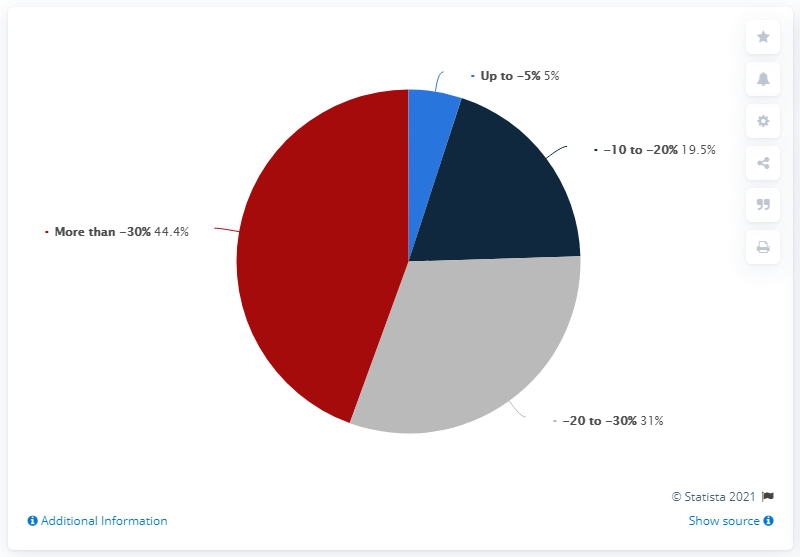Outline some significant characteristics in this image. The color blue is used to represent savings of up to 5%. The sum of the first two highest values is 75.4. 